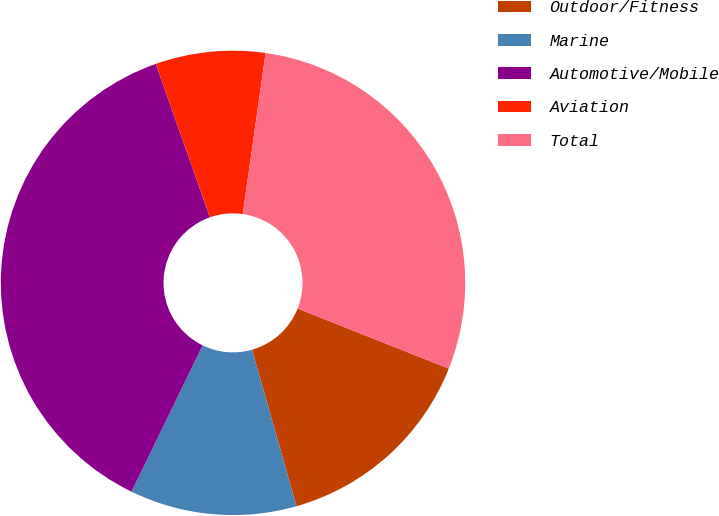Convert chart to OTSL. <chart><loc_0><loc_0><loc_500><loc_500><pie_chart><fcel>Outdoor/Fitness<fcel>Marine<fcel>Automotive/Mobile<fcel>Aviation<fcel>Total<nl><fcel>14.58%<fcel>11.61%<fcel>37.4%<fcel>7.64%<fcel>28.78%<nl></chart> 